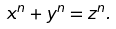<formula> <loc_0><loc_0><loc_500><loc_500>x ^ { n } + y ^ { n } = z ^ { n } .</formula> 